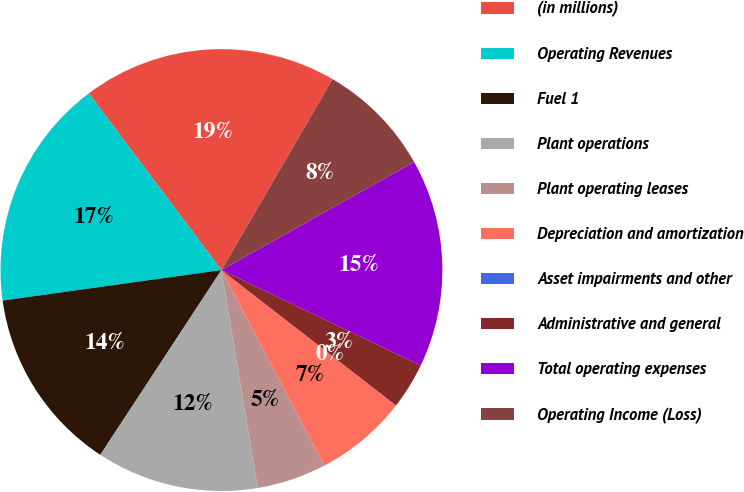Convert chart. <chart><loc_0><loc_0><loc_500><loc_500><pie_chart><fcel>(in millions)<fcel>Operating Revenues<fcel>Fuel 1<fcel>Plant operations<fcel>Plant operating leases<fcel>Depreciation and amortization<fcel>Asset impairments and other<fcel>Administrative and general<fcel>Total operating expenses<fcel>Operating Income (Loss)<nl><fcel>18.64%<fcel>16.95%<fcel>13.56%<fcel>11.86%<fcel>5.09%<fcel>6.78%<fcel>0.0%<fcel>3.39%<fcel>15.25%<fcel>8.47%<nl></chart> 